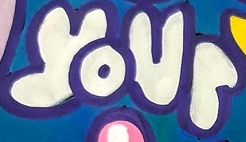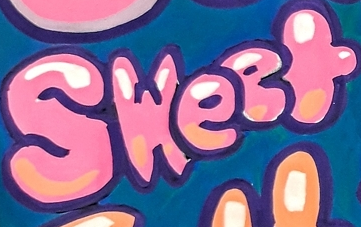What words are shown in these images in order, separated by a semicolon? your; Sweet 